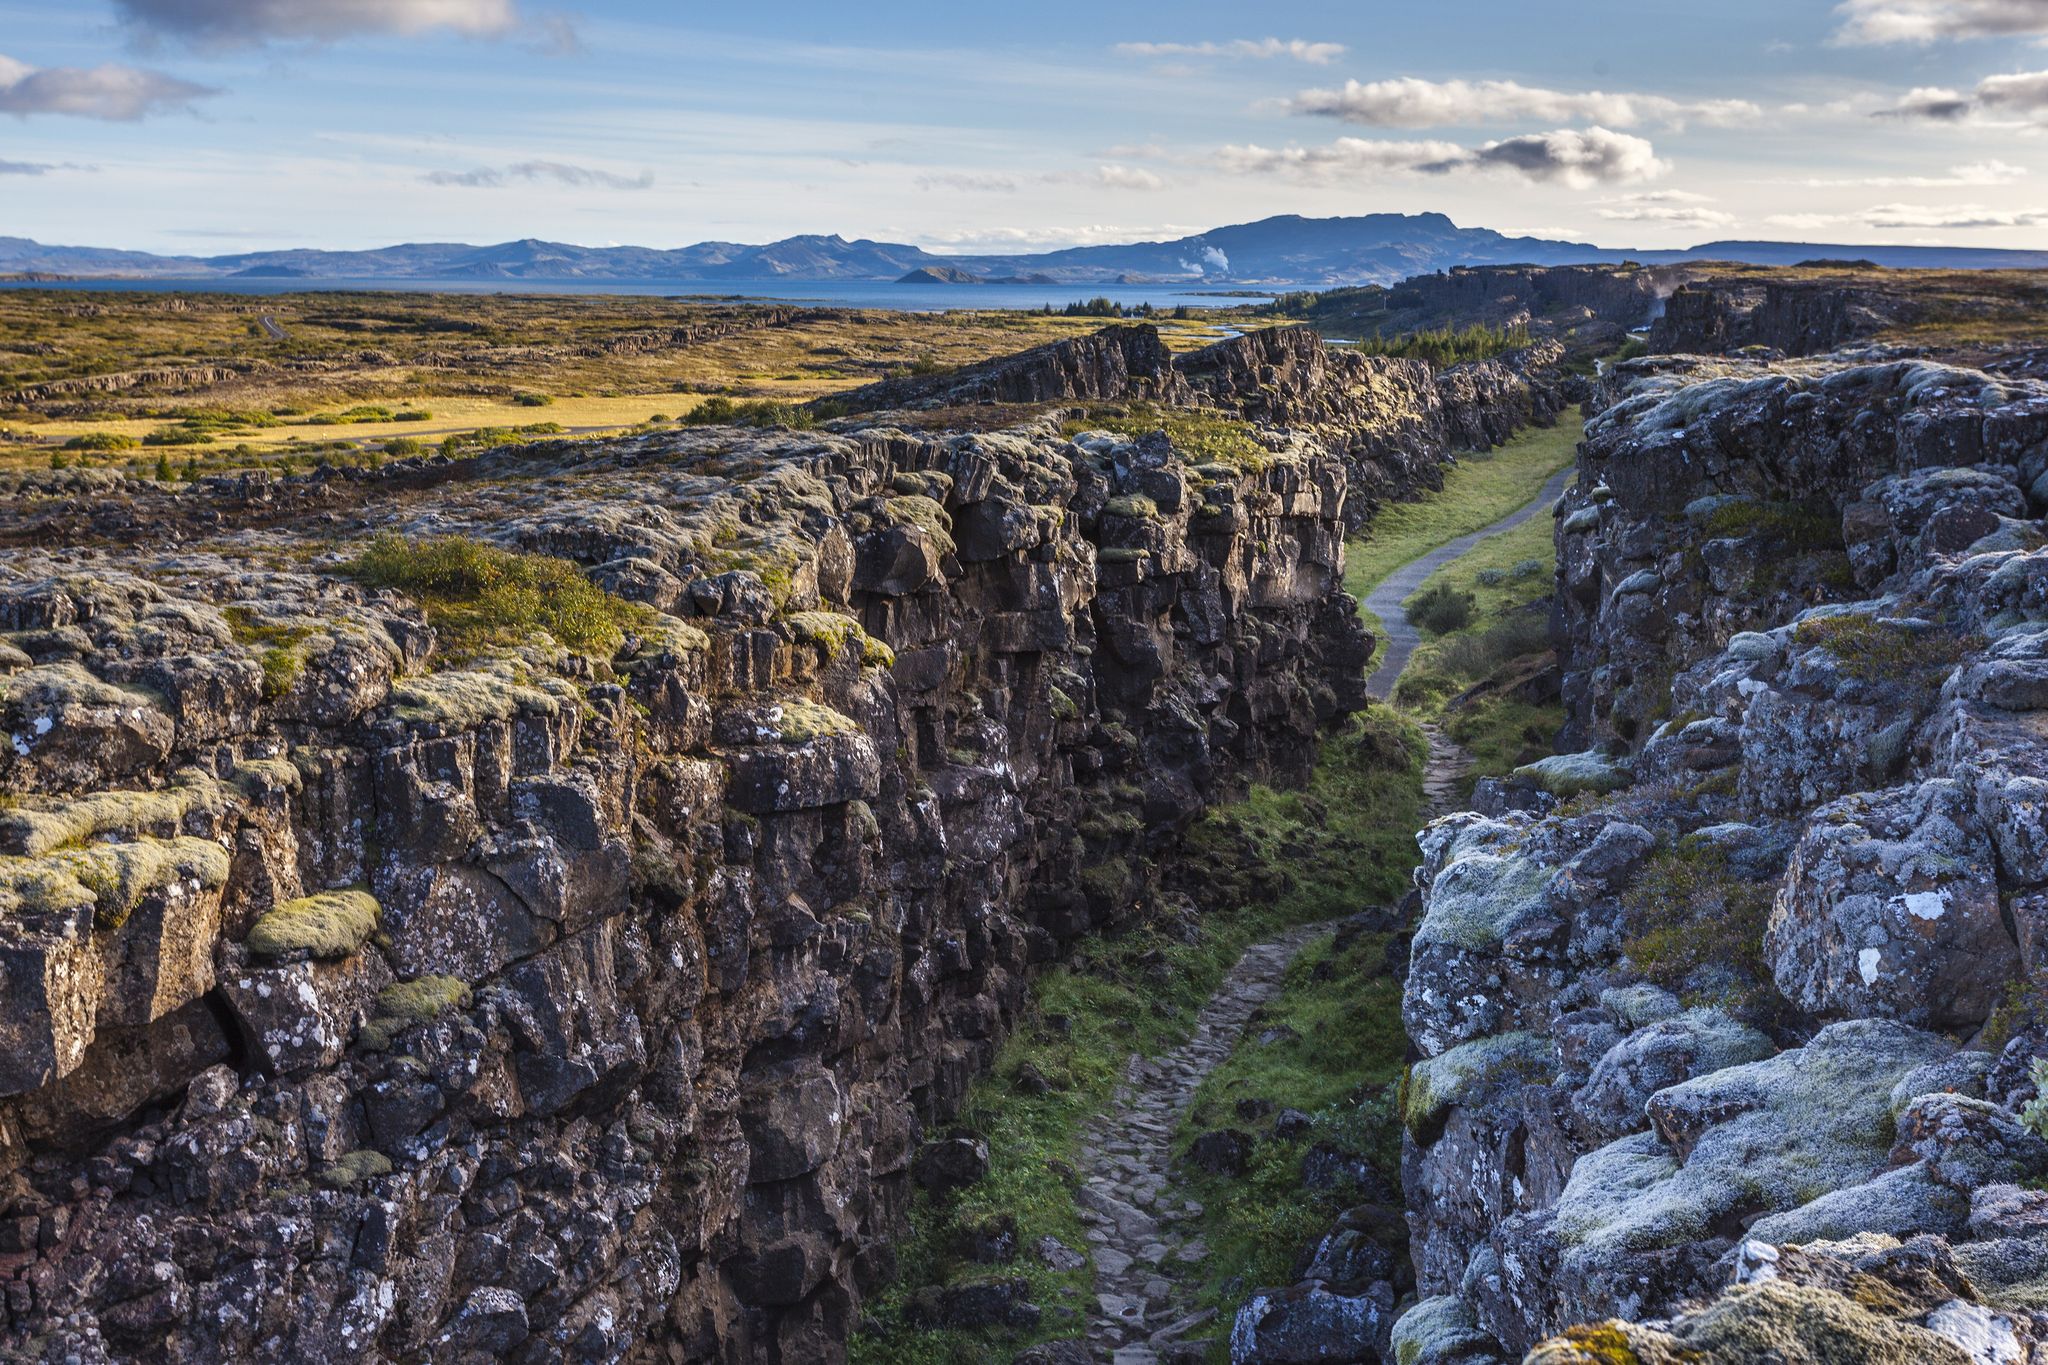How does the landscape change with the seasons at Þingvellir National Park? The landscape of Þingvellir National Park transforms beautifully with the changing seasons. In spring, the park comes alive with a vibrant display of wildflowers and budding greenery. Summer brings long days with lush vegetation, making it a perfect time for hiking and exploring. As autumn approaches, the park is painted in warm hues of gold, red, and orange, offering stunning vistas. Winter cloaks the park in a blanket of snow, creating a serene and almost otherworldly beauty. The cliffs and gorges take on a stark, ethereal appearance, and the frozen landscape offers opportunities for activities like ice diving in the Silfra fissure. 